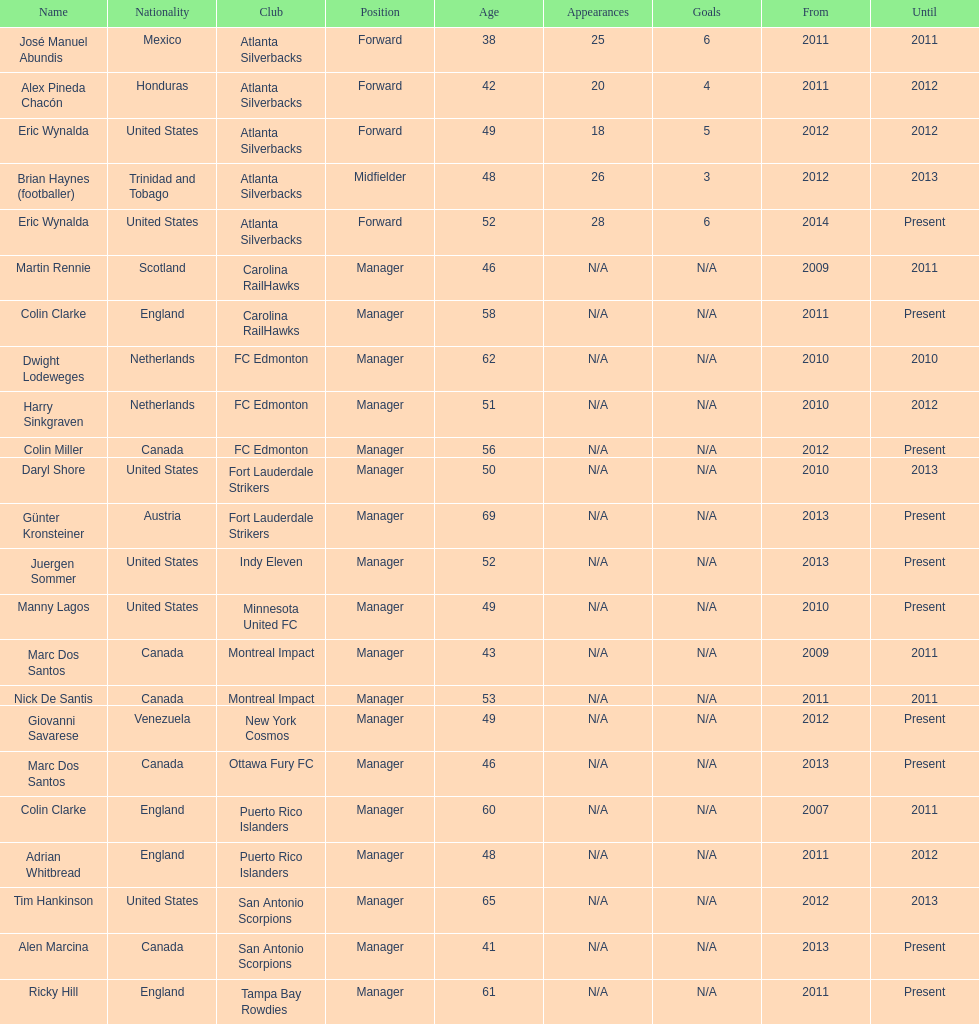Between abundis and chacon, who guided the silverbacks for a lengthier time? Chacon. 